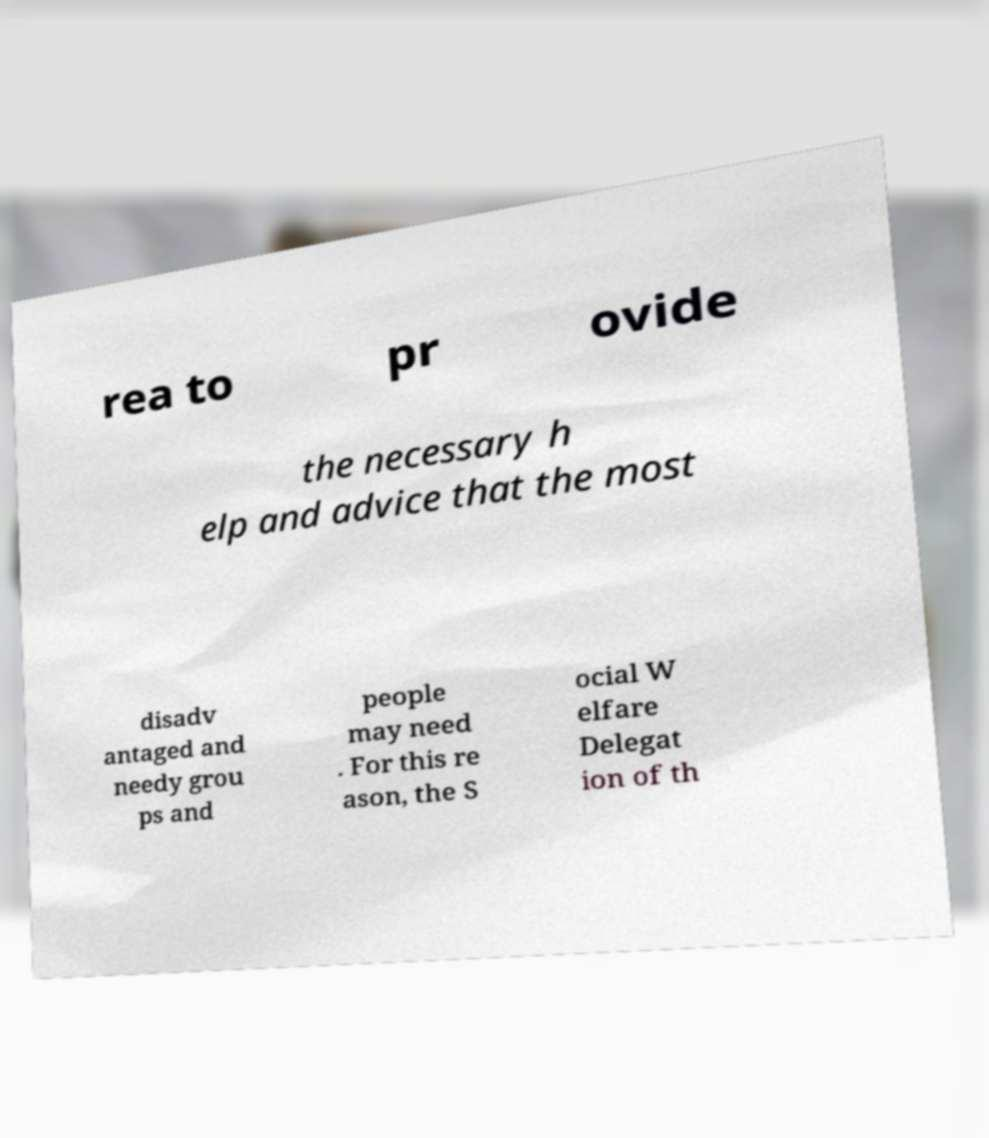Can you read and provide the text displayed in the image?This photo seems to have some interesting text. Can you extract and type it out for me? rea to pr ovide the necessary h elp and advice that the most disadv antaged and needy grou ps and people may need . For this re ason, the S ocial W elfare Delegat ion of th 